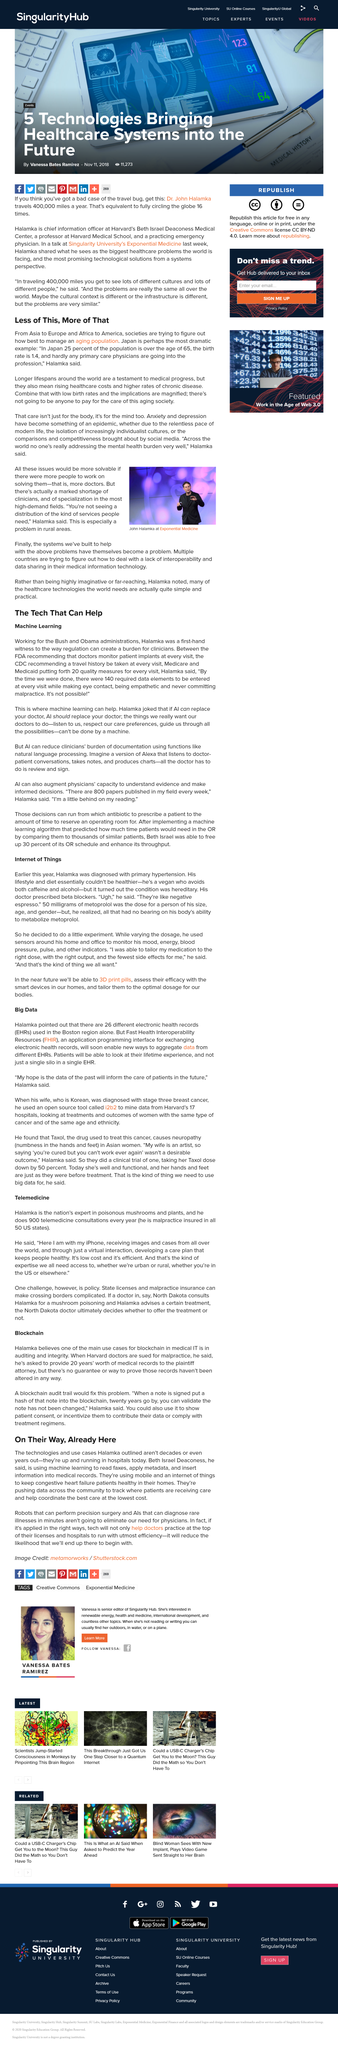Specify some key components in this picture. The dose of metoprolol for Halamka's size was 50 milligrams. The increased lifespan observed globally is a testament to the remarkable progress made in the field of medicine. Electronic health records are a digital version of a patient's medical history and are commonly referred to as EHRs. There are 26 electronic health records used in the Boston area, and Dr. Halamka hopes that the data from these records will be utilized to improve the care of future patients. Dr. Halamka worked for both the Bush and Obama administrations. 